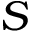<formula> <loc_0><loc_0><loc_500><loc_500>S</formula> 